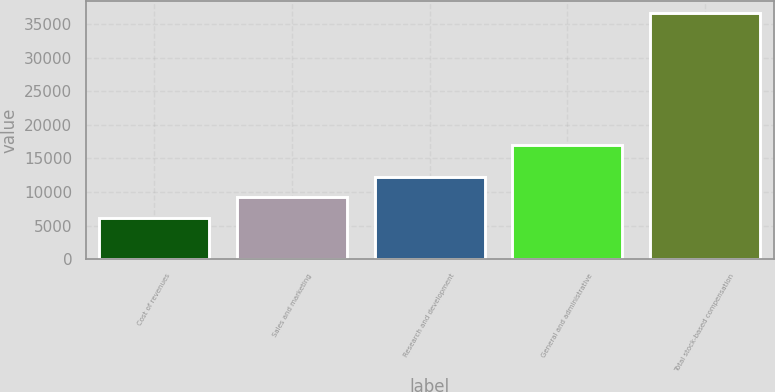Convert chart to OTSL. <chart><loc_0><loc_0><loc_500><loc_500><bar_chart><fcel>Cost of revenues<fcel>Sales and marketing<fcel>Research and development<fcel>General and administrative<fcel>Total stock-based compensation<nl><fcel>6156<fcel>9205.3<fcel>12254.6<fcel>17042<fcel>36649<nl></chart> 